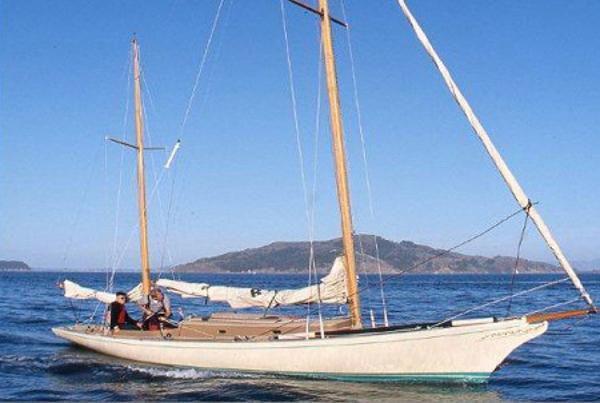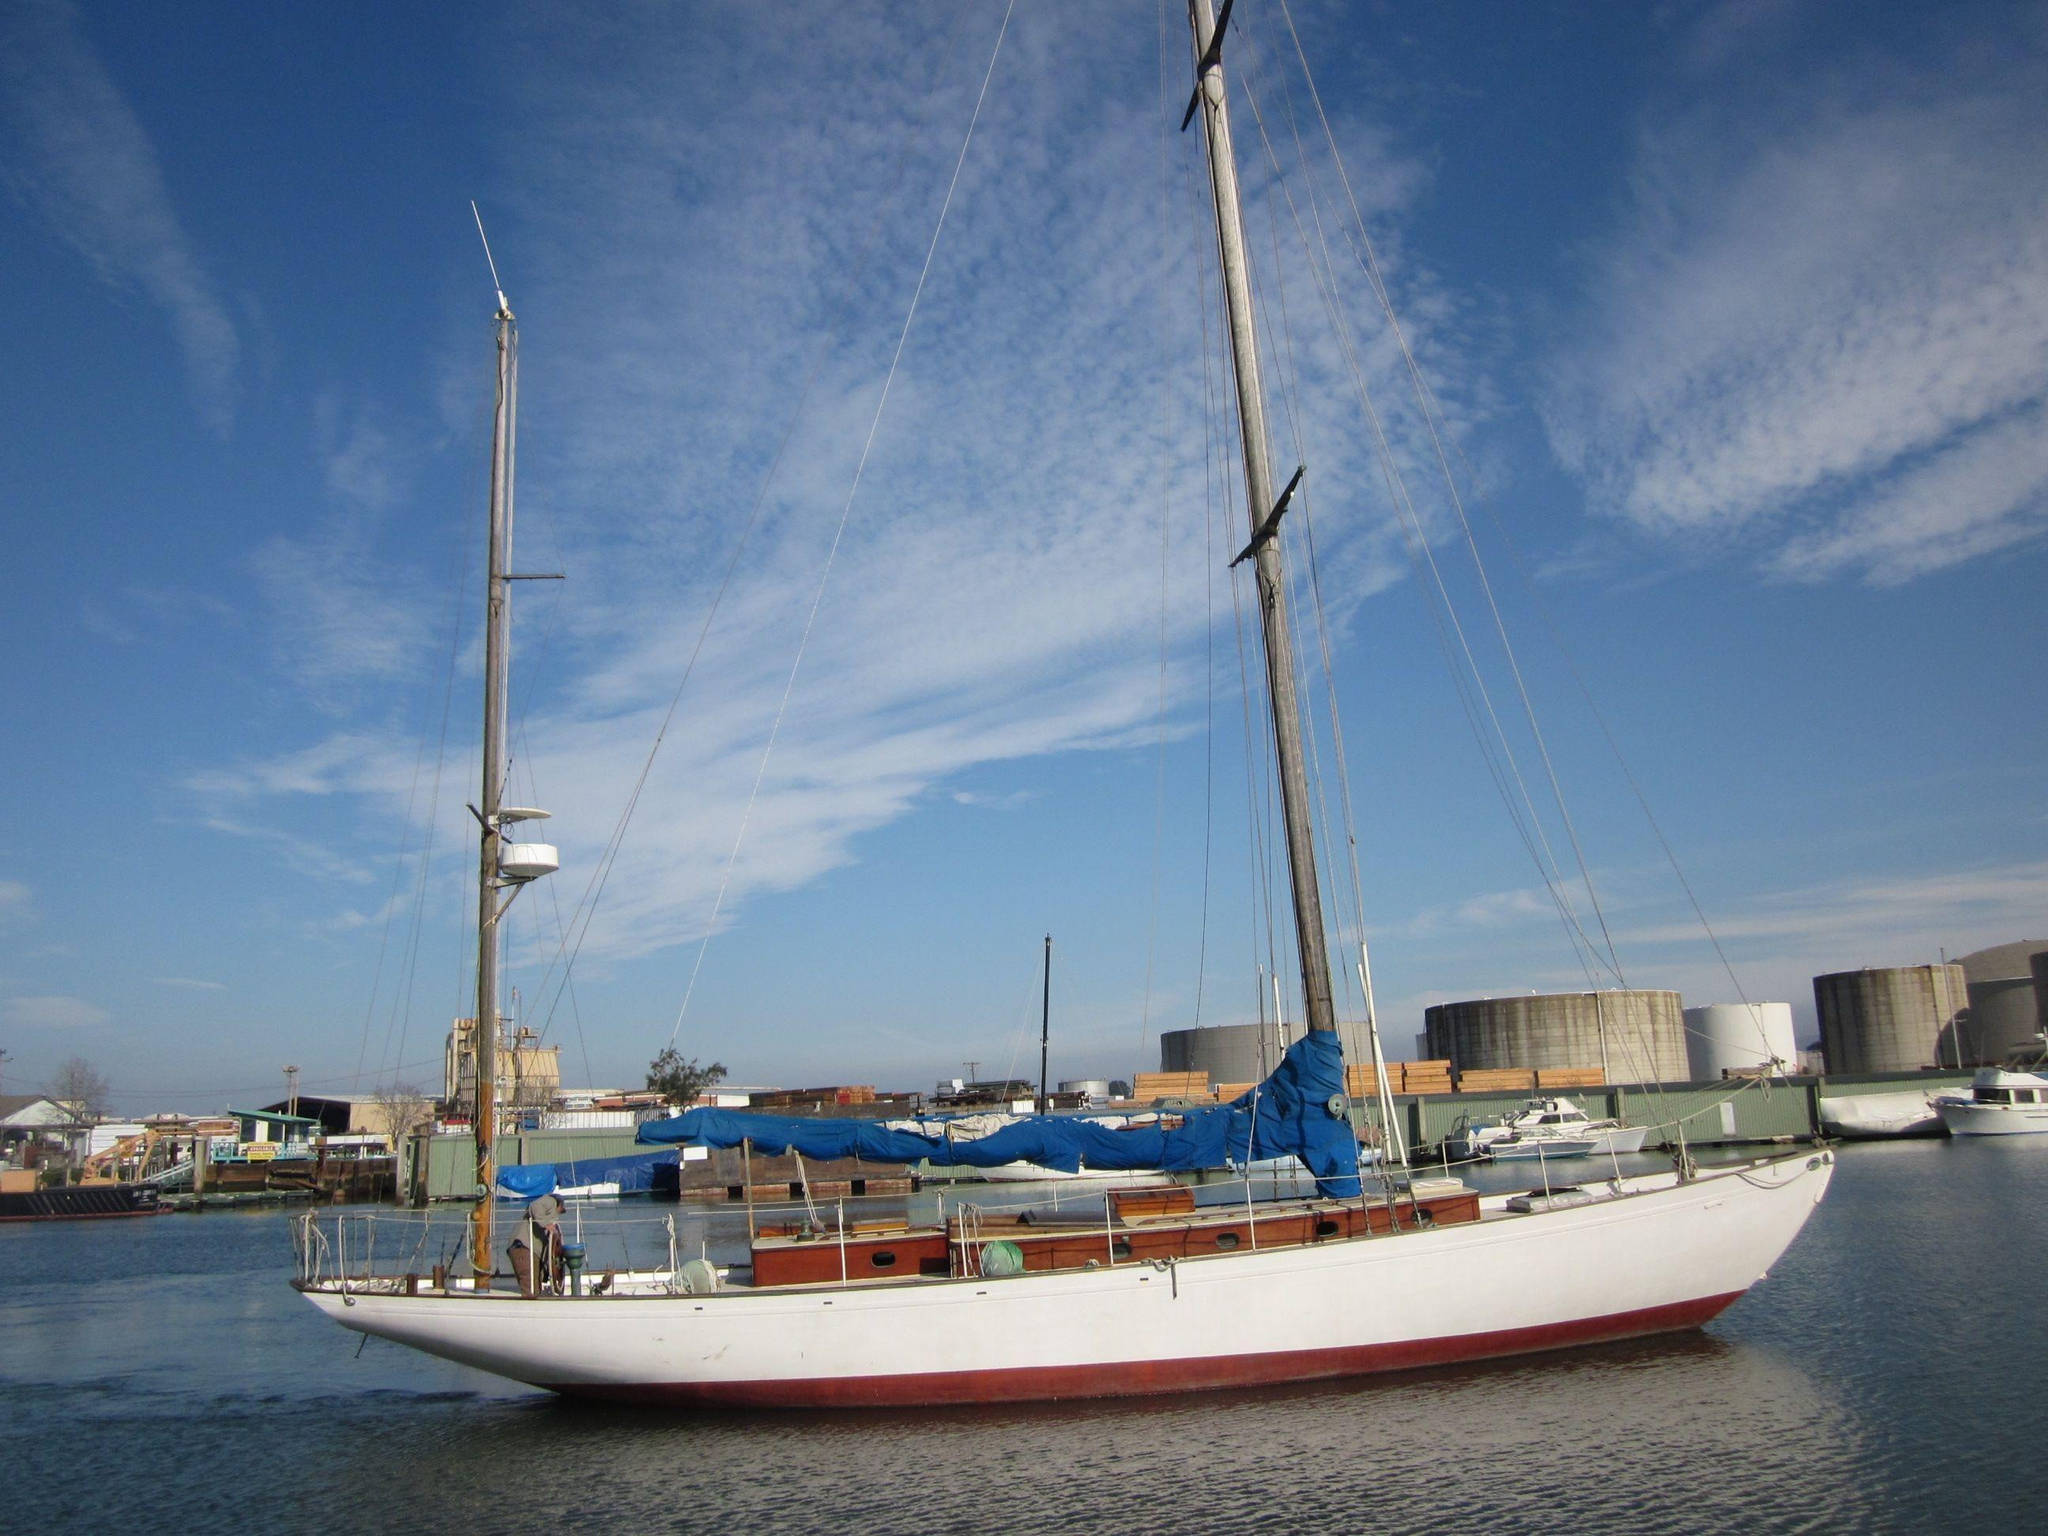The first image is the image on the left, the second image is the image on the right. Examine the images to the left and right. Is the description "At least one boat has a black body." accurate? Answer yes or no. No. The first image is the image on the left, the second image is the image on the right. For the images displayed, is the sentence "The boat on the right has a blue sail cover covering one of the sails." factually correct? Answer yes or no. Yes. 